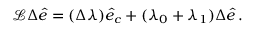<formula> <loc_0><loc_0><loc_500><loc_500>\begin{array} { r } { \mathcal { L } \Delta \hat { e } = ( \Delta \lambda ) \hat { e } _ { c } + ( \lambda _ { 0 } + \lambda _ { 1 } ) \Delta \hat { e } \, . } \end{array}</formula> 